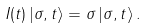<formula> <loc_0><loc_0><loc_500><loc_500>I ( t ) \left | \sigma , t \right \rangle = \sigma \left | \sigma , t \right \rangle .</formula> 